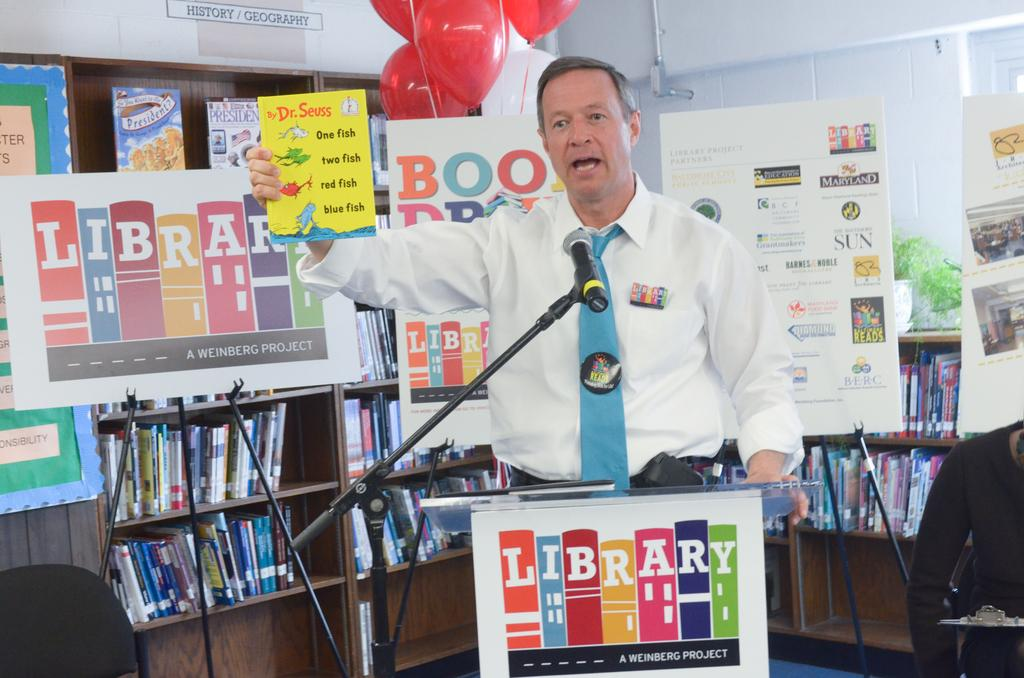Provide a one-sentence caption for the provided image. A man standing behind a sign that says Library on it. 